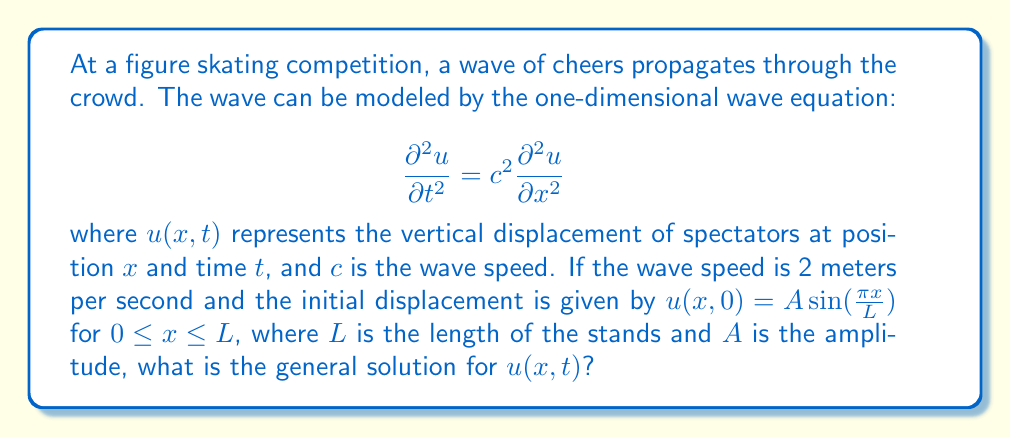Could you help me with this problem? Let's solve this step-by-step:

1) The general solution to the one-dimensional wave equation is of the form:

   $$ u(x,t) = f(x-ct) + g(x+ct) $$

   where $f$ and $g$ are arbitrary functions.

2) Given the initial condition $u(x,0) = A \sin(\frac{\pi x}{L})$, we need to find $f$ and $g$.

3) At $t=0$, we have:

   $$ u(x,0) = f(x) + g(x) = A \sin(\frac{\pi x}{L}) $$

4) We also need to consider the initial velocity condition. Since it's not given, we can assume it's zero:

   $$ \frac{\partial u}{\partial t}(x,0) = -cf'(x) + cg'(x) = 0 $$

5) From this, we can deduce that $f'(x) = g'(x)$, which means $f(x) = g(x) + \text{constant}$.

6) Using the condition from step 3, we can write:

   $$ f(x) = g(x) = \frac{A}{2} \sin(\frac{\pi x}{L}) $$

7) Now, we can write the general solution:

   $$ u(x,t) = \frac{A}{2} \sin(\frac{\pi (x-ct)}{L}) + \frac{A}{2} \sin(\frac{\pi (x+ct)}{L}) $$

8) Using the trigonometric identity for the sum of sines, this can be simplified to:

   $$ u(x,t) = A \sin(\frac{\pi x}{L}) \cos(\frac{\pi ct}{L}) $$

This is the general solution for the wave propagation in the crowd.
Answer: $$ u(x,t) = A \sin(\frac{\pi x}{L}) \cos(\frac{\pi ct}{L}) $$ 